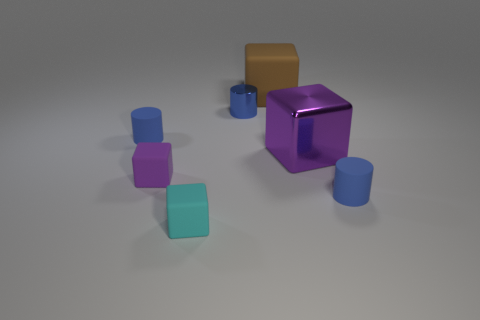There is a purple block that is right of the cyan rubber object; does it have the same size as the purple block that is in front of the shiny block?
Provide a short and direct response. No. What number of objects are small blue matte cylinders on the left side of the purple shiny block or blocks that are on the right side of the shiny cylinder?
Provide a succinct answer. 3. Are there any other things that have the same shape as the small purple thing?
Make the answer very short. Yes. Does the small matte object that is right of the cyan thing have the same color as the rubber cylinder that is to the left of the cyan rubber object?
Provide a short and direct response. Yes. How many shiny objects are either cyan objects or tiny purple objects?
Offer a terse response. 0. Is there any other thing that is the same size as the cyan rubber object?
Your response must be concise. Yes. What is the shape of the big purple metal object left of the blue matte thing that is in front of the purple metal thing?
Give a very brief answer. Cube. Do the purple thing in front of the large metal cube and the tiny blue cylinder that is left of the tiny cyan block have the same material?
Offer a terse response. Yes. There is a tiny blue rubber cylinder that is to the left of the small purple matte cube; what number of large purple blocks are behind it?
Your answer should be very brief. 0. Is the shape of the purple thing that is to the right of the cyan matte thing the same as the blue rubber object that is on the right side of the large matte block?
Offer a terse response. No. 